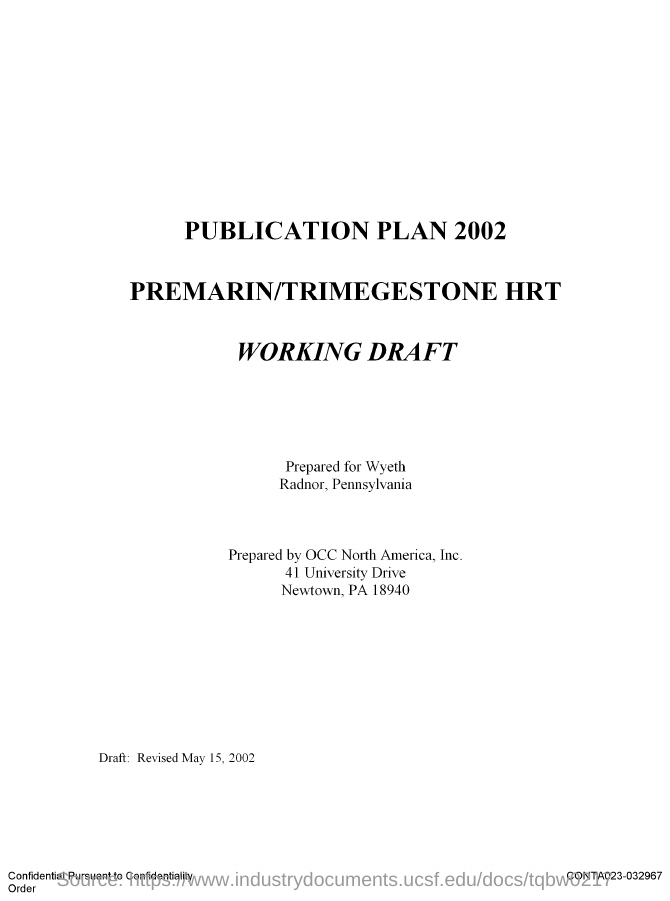What is the ZIP code?
Ensure brevity in your answer.  18940. 